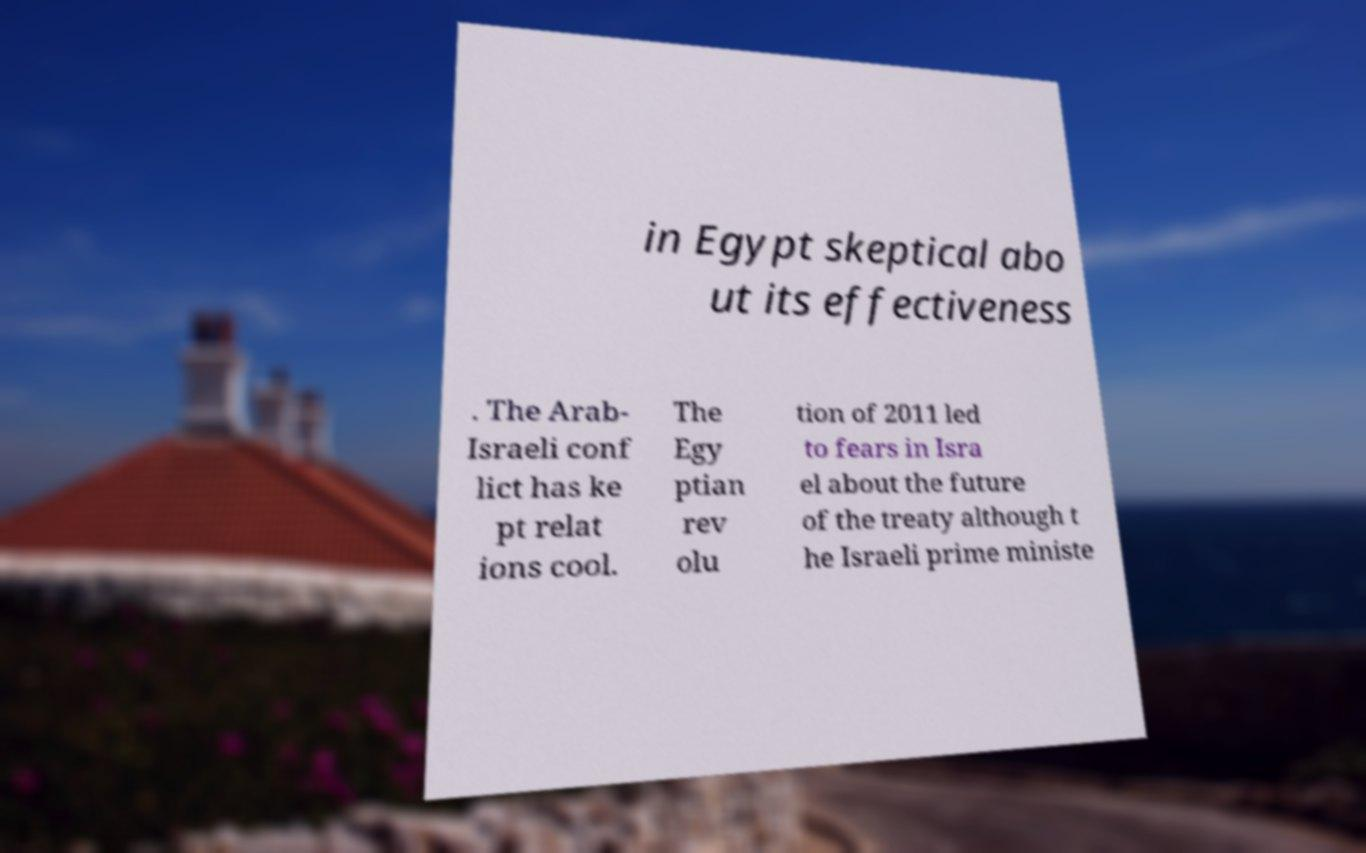Please read and relay the text visible in this image. What does it say? in Egypt skeptical abo ut its effectiveness . The Arab- Israeli conf lict has ke pt relat ions cool. The Egy ptian rev olu tion of 2011 led to fears in Isra el about the future of the treaty although t he Israeli prime ministe 